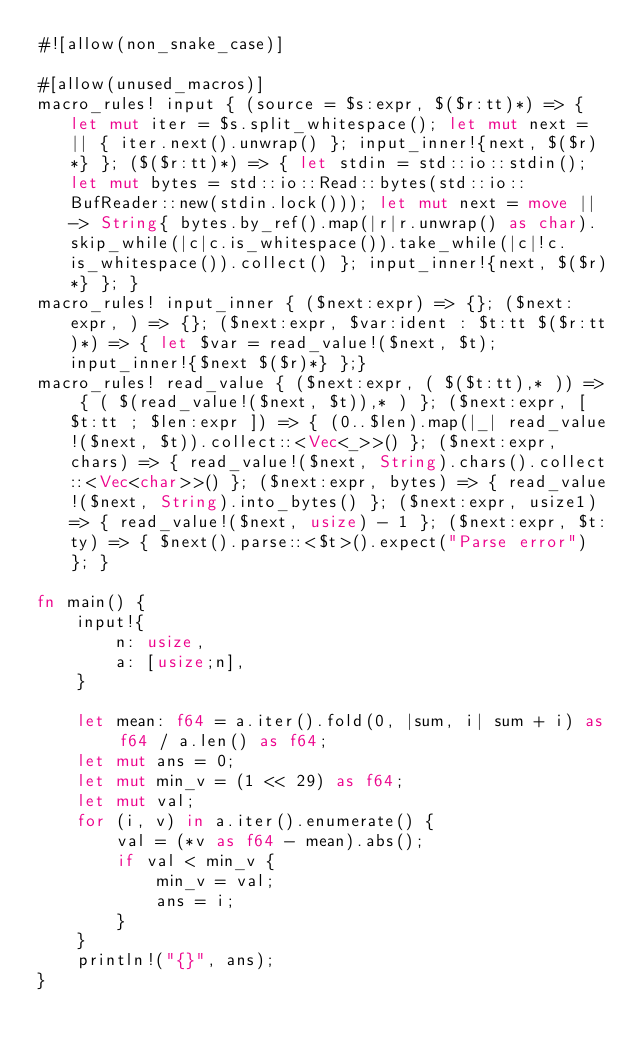Convert code to text. <code><loc_0><loc_0><loc_500><loc_500><_Rust_>#![allow(non_snake_case)]

#[allow(unused_macros)]
macro_rules! input { (source = $s:expr, $($r:tt)*) => { let mut iter = $s.split_whitespace(); let mut next = || { iter.next().unwrap() }; input_inner!{next, $($r)*} }; ($($r:tt)*) => { let stdin = std::io::stdin(); let mut bytes = std::io::Read::bytes(std::io::BufReader::new(stdin.lock())); let mut next = move || -> String{ bytes.by_ref().map(|r|r.unwrap() as char).skip_while(|c|c.is_whitespace()).take_while(|c|!c.is_whitespace()).collect() }; input_inner!{next, $($r)*} }; }
macro_rules! input_inner { ($next:expr) => {}; ($next:expr, ) => {}; ($next:expr, $var:ident : $t:tt $($r:tt)*) => { let $var = read_value!($next, $t); input_inner!{$next $($r)*} };}
macro_rules! read_value { ($next:expr, ( $($t:tt),* )) => { ( $(read_value!($next, $t)),* ) }; ($next:expr, [ $t:tt ; $len:expr ]) => { (0..$len).map(|_| read_value!($next, $t)).collect::<Vec<_>>() }; ($next:expr, chars) => { read_value!($next, String).chars().collect::<Vec<char>>() }; ($next:expr, bytes) => { read_value!($next, String).into_bytes() }; ($next:expr, usize1) => { read_value!($next, usize) - 1 }; ($next:expr, $t:ty) => { $next().parse::<$t>().expect("Parse error") }; }

fn main() {
    input!{
        n: usize,
        a: [usize;n],
    }

    let mean: f64 = a.iter().fold(0, |sum, i| sum + i) as f64 / a.len() as f64;
    let mut ans = 0;
    let mut min_v = (1 << 29) as f64;
    let mut val;
    for (i, v) in a.iter().enumerate() {
        val = (*v as f64 - mean).abs();
        if val < min_v {
            min_v = val;
            ans = i;
        }
    }
    println!("{}", ans);
}</code> 